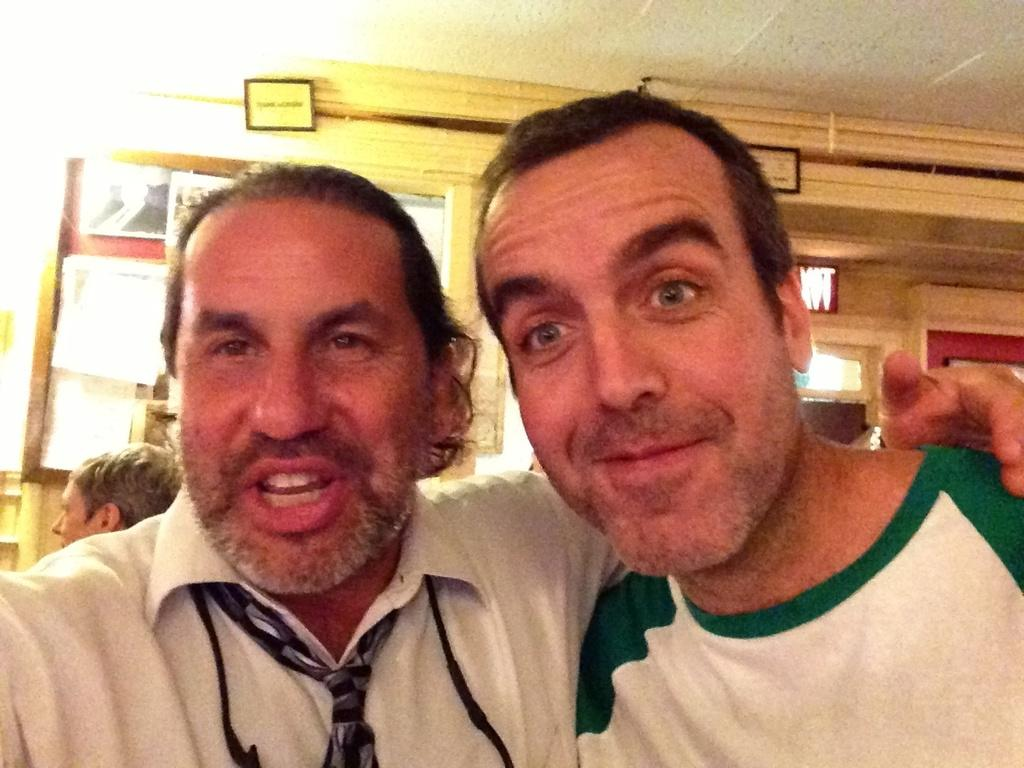How many people are in the image? There are three persons in the image. What can be seen on the board in the image? There is a board with posters in the image. What is visible on the wall in the background of the image? There are additional boards attached to the wall in the background of the image. What type of toy is being used by one of the persons in the image? There is no toy visible in the image; the three persons are not interacting with any toys. 